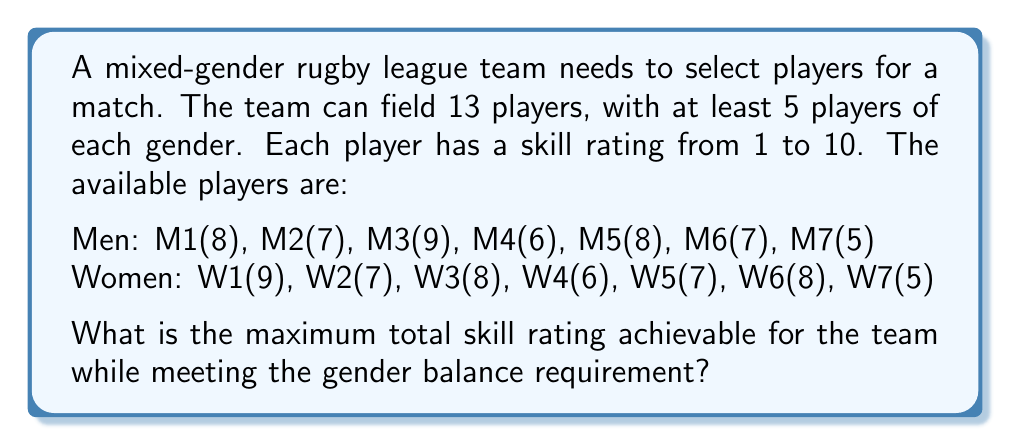Could you help me with this problem? To solve this optimization problem, we'll use the following approach:

1) First, we need to select the minimum required number of players from each gender:
   5 men and 5 women.

2) Then, we'll fill the remaining 3 spots with the highest-rated available players, regardless of gender.

3) Let's sort the players by their skill ratings:

   Men: M3(9), M1(8), M5(8), M2(7), M6(7), M4(6), M7(5)
   Women: W1(9), W3(8), W6(8), W2(7), W5(7), W4(6), W7(5)

4) Select the top 5 from each gender:
   Men: M3(9), M1(8), M5(8), M2(7), M6(7)
   Women: W1(9), W3(8), W6(8), W2(7), W5(7)

5) Sum of ratings so far:
   $$(9 + 8 + 8 + 7 + 7) + (9 + 8 + 8 + 7 + 7) = 39 + 39 = 78$$

6) For the remaining 3 spots, select the highest-rated players left:
   M4(6), W4(6), M7(5) or W7(5)

7) Add these to the sum:
   $$78 + 6 + 6 + 5 = 95$$

Therefore, the maximum total skill rating achievable is 95.
Answer: 95 